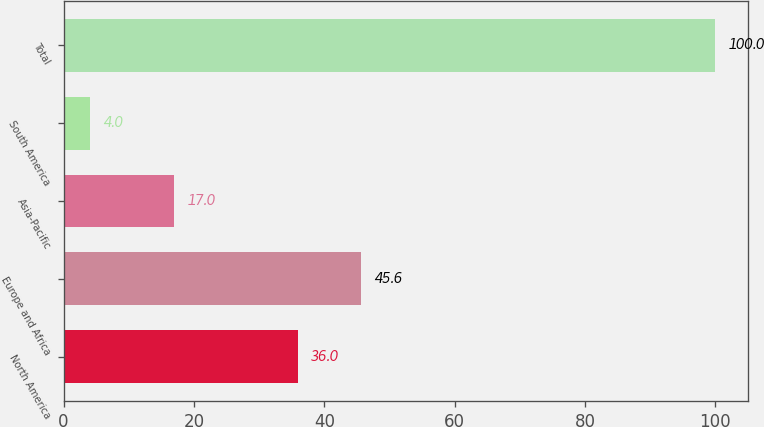Convert chart to OTSL. <chart><loc_0><loc_0><loc_500><loc_500><bar_chart><fcel>North America<fcel>Europe and Africa<fcel>Asia-Pacific<fcel>South America<fcel>Total<nl><fcel>36<fcel>45.6<fcel>17<fcel>4<fcel>100<nl></chart> 